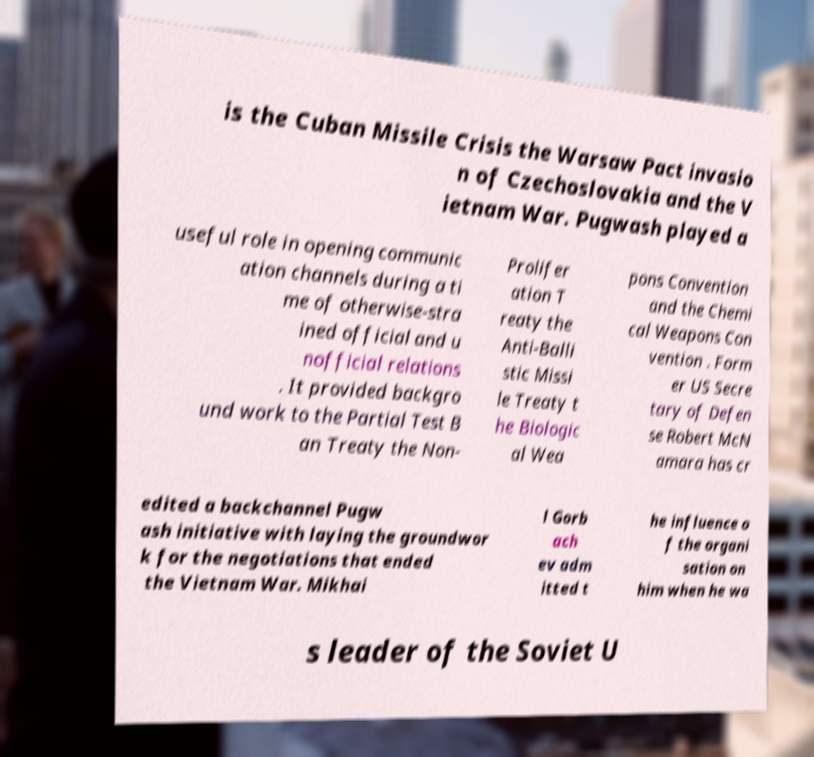For documentation purposes, I need the text within this image transcribed. Could you provide that? is the Cuban Missile Crisis the Warsaw Pact invasio n of Czechoslovakia and the V ietnam War. Pugwash played a useful role in opening communic ation channels during a ti me of otherwise-stra ined official and u nofficial relations . It provided backgro und work to the Partial Test B an Treaty the Non- Prolifer ation T reaty the Anti-Balli stic Missi le Treaty t he Biologic al Wea pons Convention and the Chemi cal Weapons Con vention . Form er US Secre tary of Defen se Robert McN amara has cr edited a backchannel Pugw ash initiative with laying the groundwor k for the negotiations that ended the Vietnam War. Mikhai l Gorb ach ev adm itted t he influence o f the organi sation on him when he wa s leader of the Soviet U 